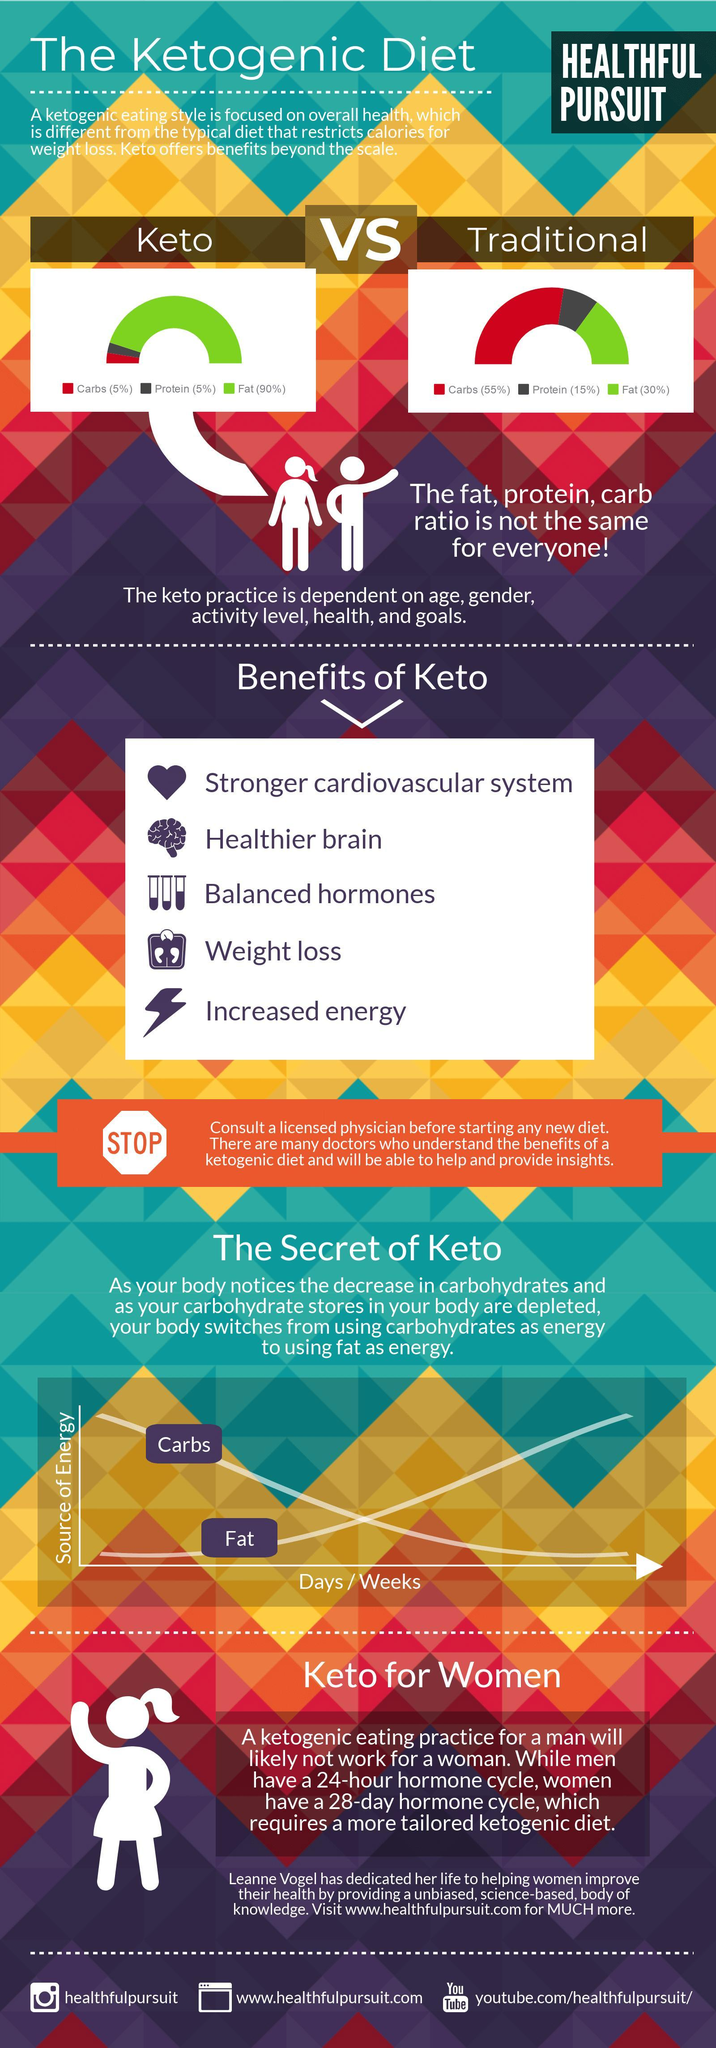What percent of fat should be incorporated in a Keto diet?
Answer the question with a short phrase. 90% 